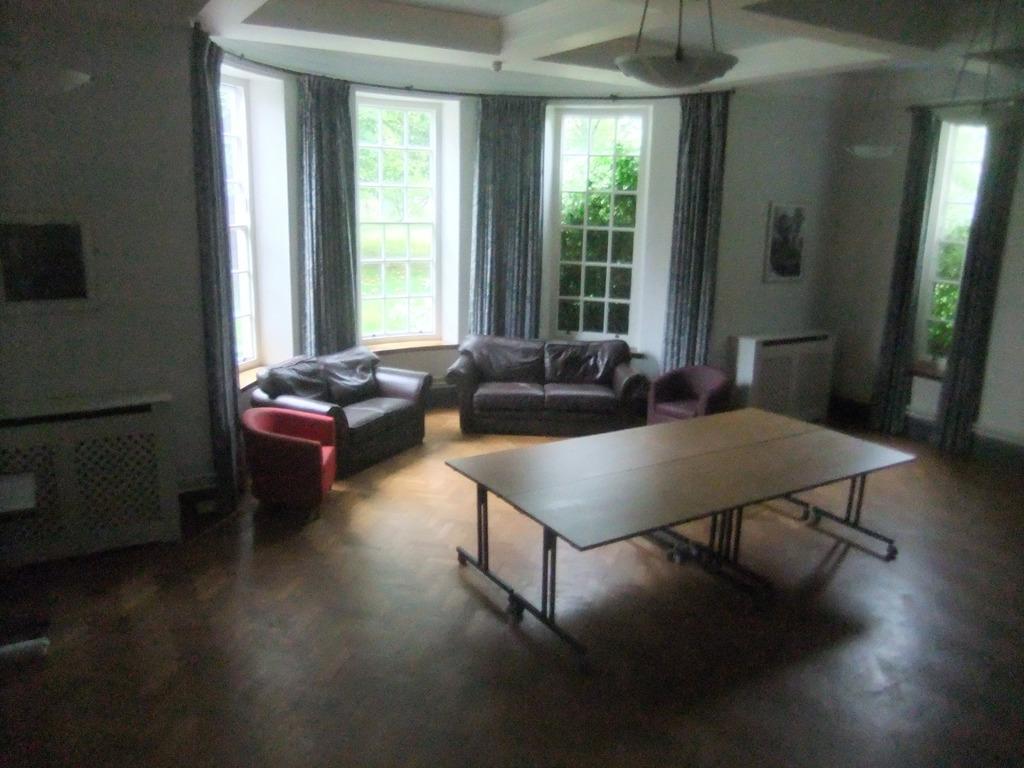Describe this image in one or two sentences. In this image in the center there are two couches and two chairs and in the middle there is a window and curtains are there and on the right side there is another window and curtains are there and on the left side there is a wall. Behind that wall there is one table and in the center there is on table on the ceiling there is one light. 